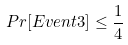<formula> <loc_0><loc_0><loc_500><loc_500>P r [ E v e n t 3 ] \leq \frac { 1 } { 4 }</formula> 